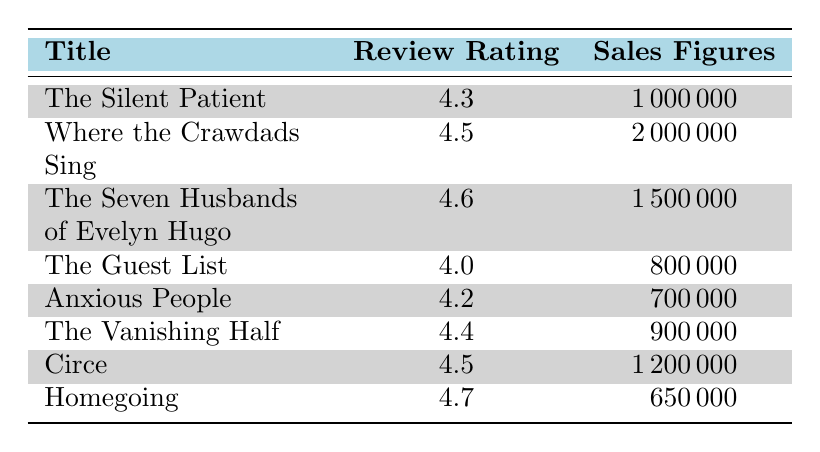What is the review rating for "Where the Crawdads Sing"? The table shows that the review rating for "Where the Crawdads Sing" is directly listed as 4.5.
Answer: 4.5 What are the sales figures for "Circe"? According to the table, the sales figures for "Circe" are noted as 1,200,000.
Answer: 1,200,000 Which novel has the highest review rating? By examining the review ratings for each novel in the table, "Homegoing" has the highest review rating at 4.7.
Answer: Homegoing What is the total sales figure for novels with a review rating of 4.5 and above? The novels with ratings of 4.5 and above are "Where the Crawdads Sing" (2,000,000), "The Seven Husbands of Evelyn Hugo" (1,500,000), "Circe" (1,200,000), and "Homegoing" (650,000). Adding these figures together: 2,000,000 + 1,500,000 + 1,200,000 + 650,000 = 5,350,000.
Answer: 5,350,000 Is the review rating of "The Silent Patient" higher than that of "The Guest List"? The review rating of "The Silent Patient" is 4.3 and that of "The Guest List" is 4.0. Since 4.3 is greater than 4.0, the answer is yes.
Answer: Yes How many novels have sales figures greater than 1 million? By checking the sales figures, "Where the Crawdads Sing" (2,000,000), "The Silent Patient" (1,000,000), "The Seven Husbands of Evelyn Hugo" (1,500,000), and "Circe" (1,200,000) have sales numbers exceeding 1 million. There are four novels that meet this criterion.
Answer: 4 What is the average review rating of all the novels listed in the table? The review ratings are 4.3, 4.5, 4.6, 4.0, 4.2, 4.4, 4.5, and 4.7. Summing these ratings gives 36.2. There are 8 novels, so the average is 36.2 / 8 = 4.525.
Answer: 4.525 Is "Anxious People" the lowest-rated novel in the list? Looking at the review ratings, "Anxious People" has a rating of 4.2, while "The Guest List" has a lower rating of 4.0. Therefore, "The Guest List" is the lowest-rated, making the statement false.
Answer: No 